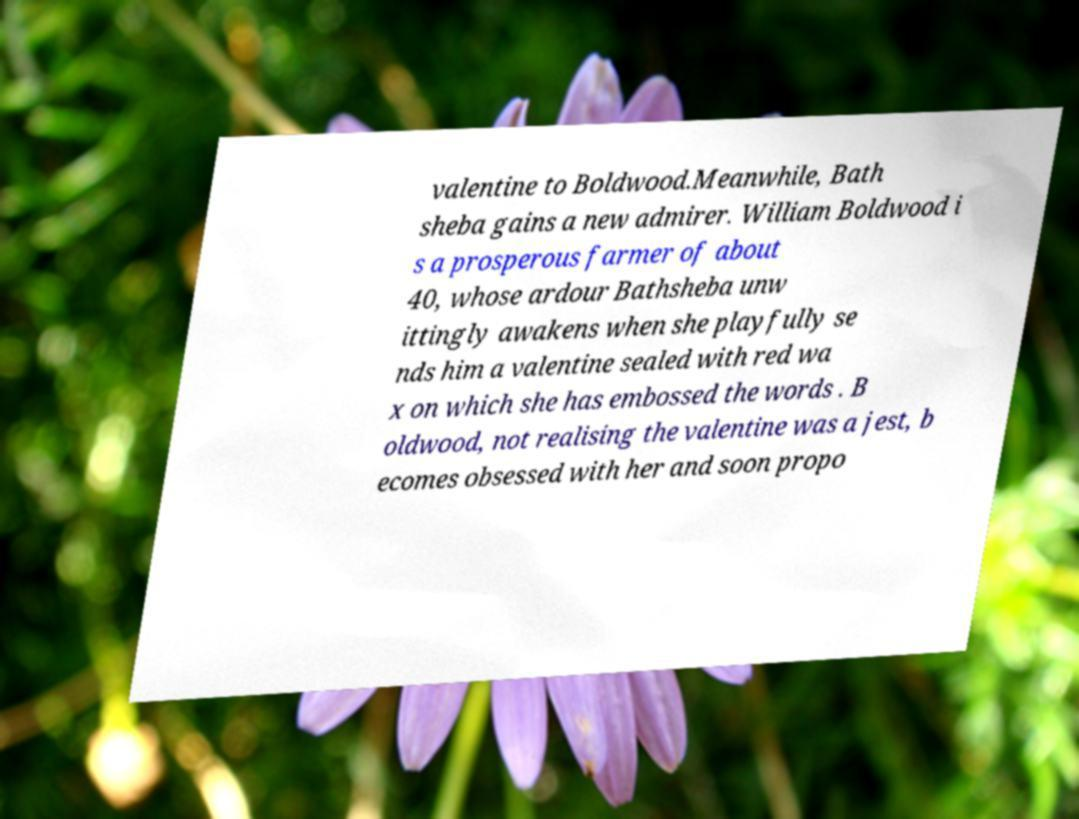What messages or text are displayed in this image? I need them in a readable, typed format. valentine to Boldwood.Meanwhile, Bath sheba gains a new admirer. William Boldwood i s a prosperous farmer of about 40, whose ardour Bathsheba unw ittingly awakens when she playfully se nds him a valentine sealed with red wa x on which she has embossed the words . B oldwood, not realising the valentine was a jest, b ecomes obsessed with her and soon propo 